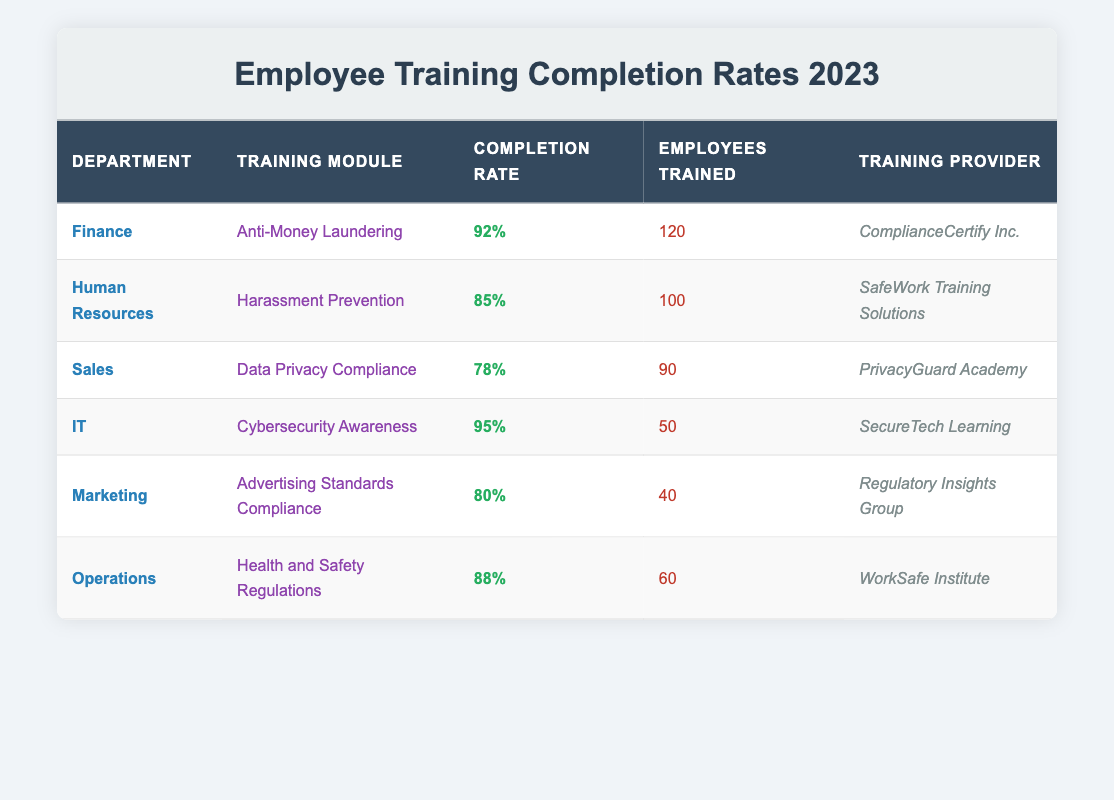What is the completion rate for the IT department's training? Referring to the table, the IT department's training module is Cybersecurity Awareness, which has a completion rate listed as 95%.
Answer: 95% Which department had the highest number of employees trained? By comparing the "Employees Trained" column across all departments, Finance has 120 employees trained, which is higher than any other department listed.
Answer: Finance What is the average completion rate across all departments? To find the average, add the completion rates: (92 + 85 + 78 + 95 + 80 + 88) = 518. Since there are 6 departments, divide 518 by 6, which gives an average completion rate of approximately 86.33%.
Answer: 86.33% Is it true that more than 80% of the Marketing department completed their training? The completion rate for Marketing is 80%, which does not exceed 80%. Therefore, the statement is false.
Answer: No Which training module had the lowest completion rate? By reviewing the "Completion Rate" column, Data Privacy Compliance from the Sales department shows the lowest completion rate at 78%.
Answer: Data Privacy Compliance How many employees were trained in the Operations department compared to the Sales department? Operations had 60 employees trained while Sales had 90. Since 90 is greater than 60, we find that Sales had more employees trained.
Answer: Sales had more employees trained What percentage difference exists between the completion rates of the IT and HR departments? The completion rate for IT is 95% and for HR, it is 85%. The difference is 95 - 85 = 10%. To find the percentage difference (relative to HR), we use (10/85) * 100, which is approximately 11.76%.
Answer: Approximately 11.76% Did ComplianceCertify Inc. provide training for the highest completion rate module? Yes, the Finance department with its Anti-Money Laundering training has the highest completion rate at 92%, and it was provided by ComplianceCertify Inc.
Answer: Yes What is the total number of employees trained across all departments? Adding the "Employees Trained" values together: 120 (Finance) + 100 (HR) + 90 (Sales) + 50 (IT) + 40 (Marketing) + 60 (Operations) = 500 employees.
Answer: 500 